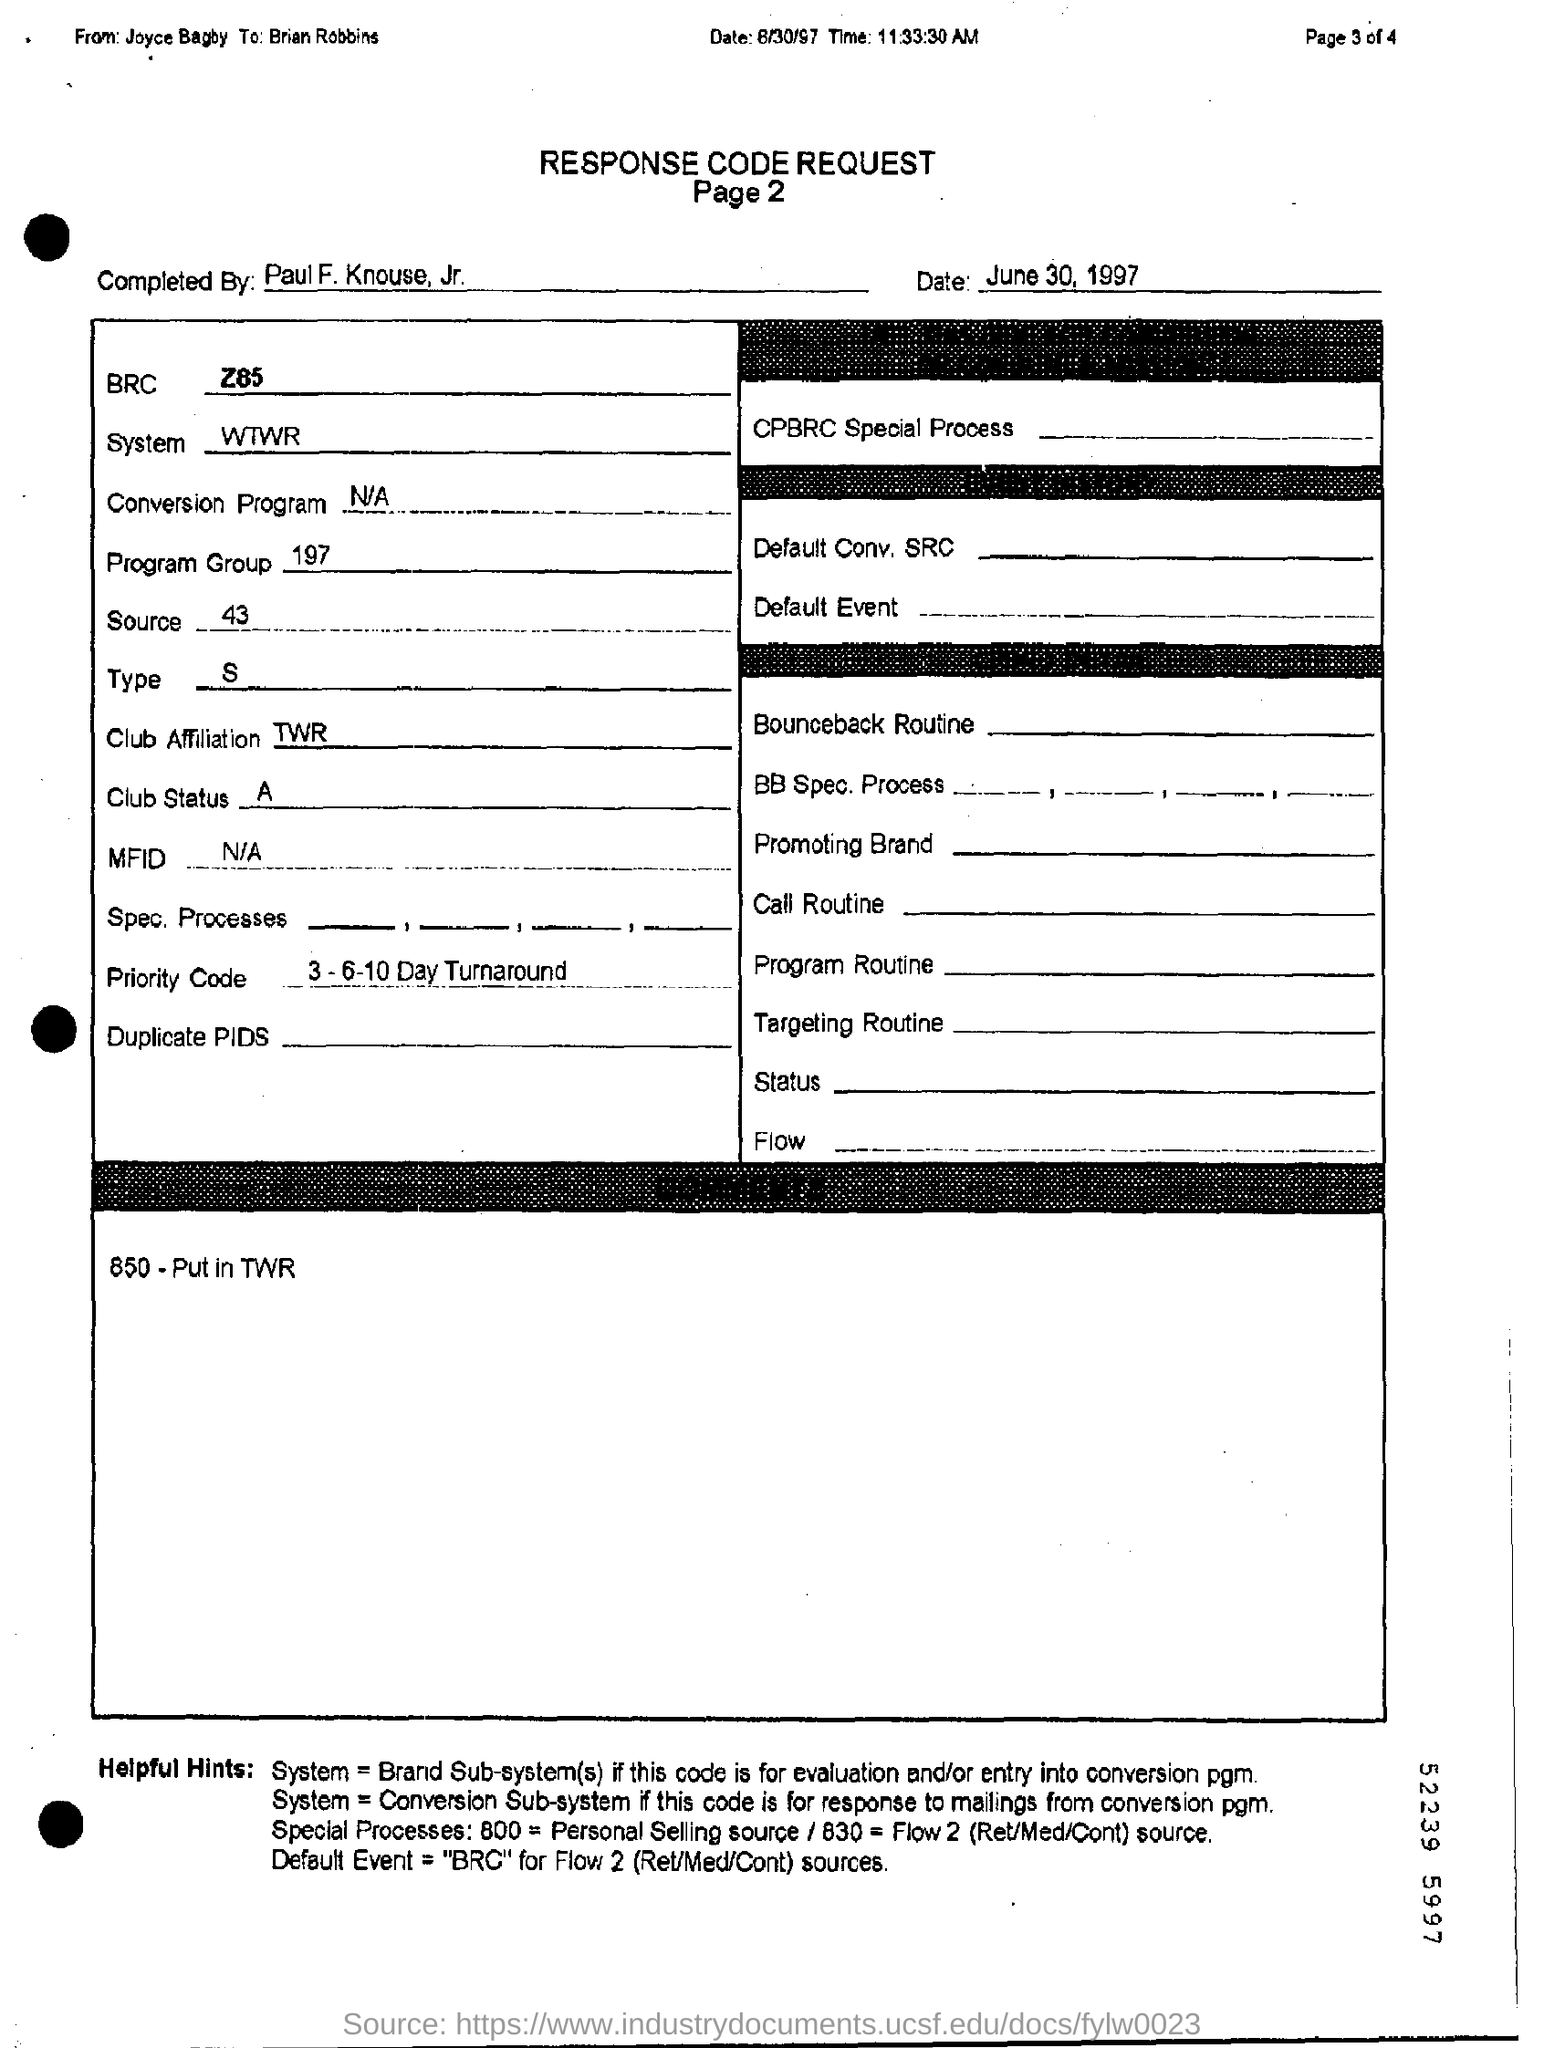Who send the request?
Give a very brief answer. Joyce Bagby. Which is the date of request?
Give a very brief answer. June 30, 1997. What is the program group?
Provide a succinct answer. 197. Which Program Group is mentioned?
Provide a short and direct response. 197. 